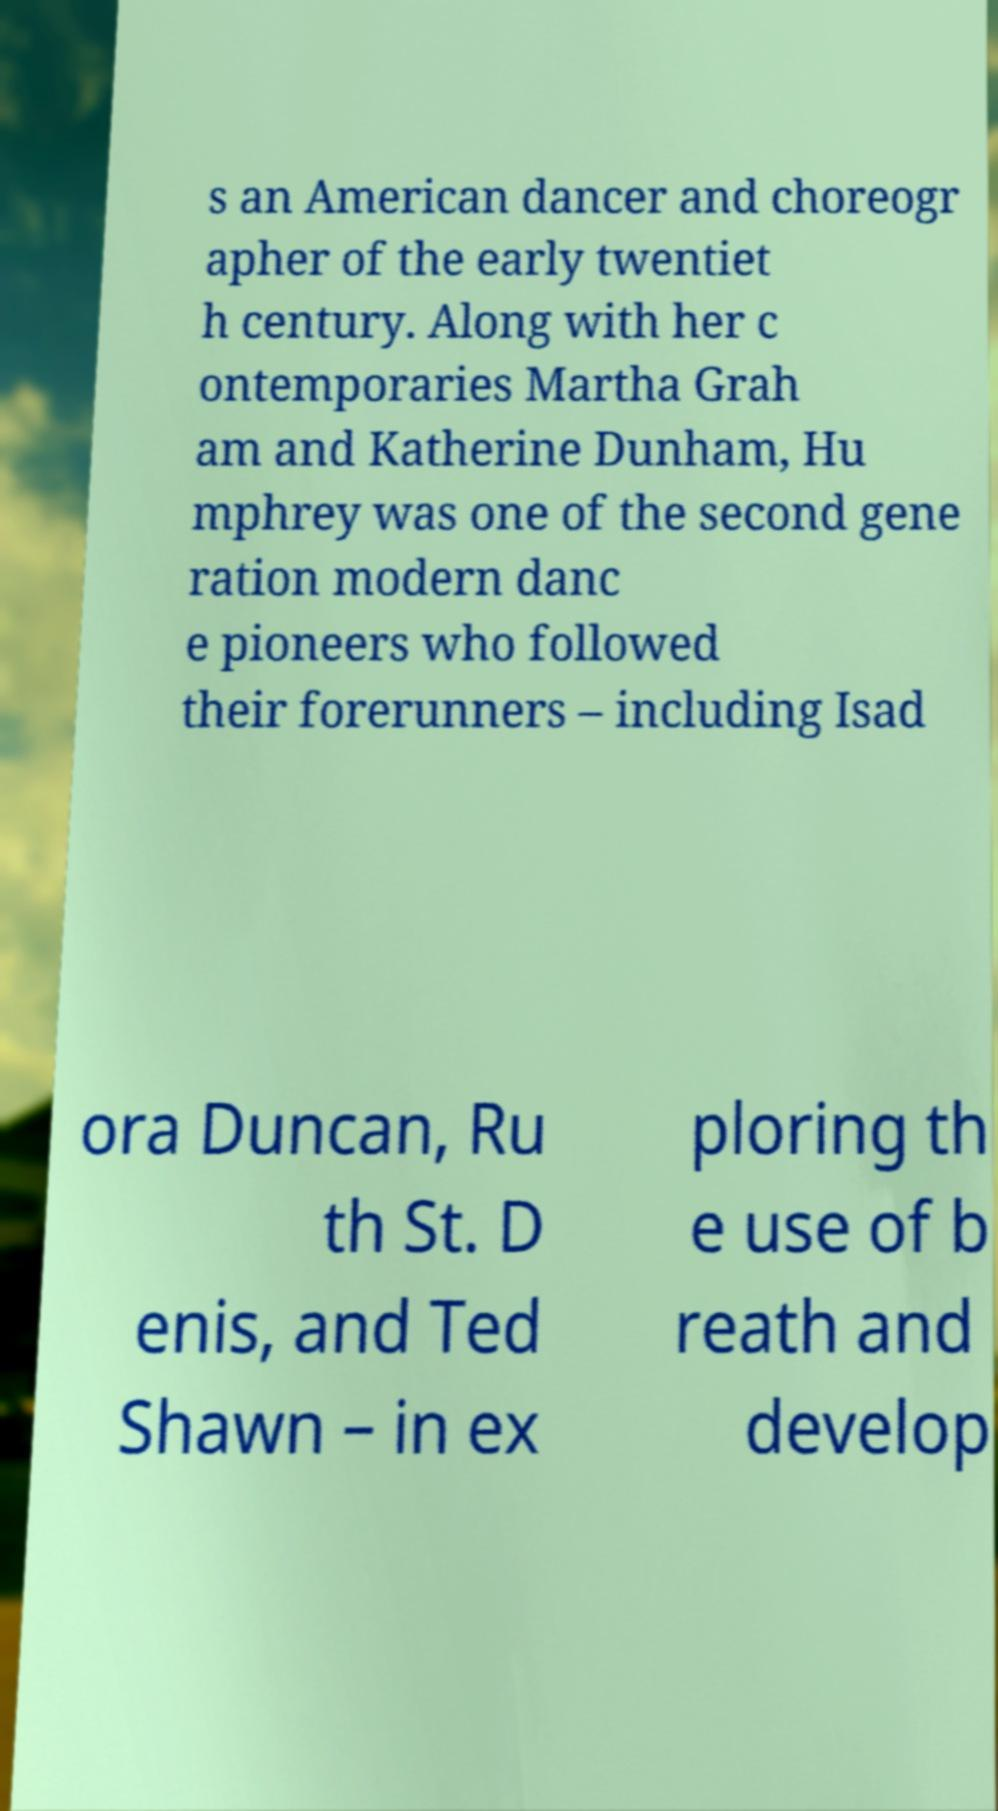Could you extract and type out the text from this image? s an American dancer and choreogr apher of the early twentiet h century. Along with her c ontemporaries Martha Grah am and Katherine Dunham, Hu mphrey was one of the second gene ration modern danc e pioneers who followed their forerunners – including Isad ora Duncan, Ru th St. D enis, and Ted Shawn – in ex ploring th e use of b reath and develop 